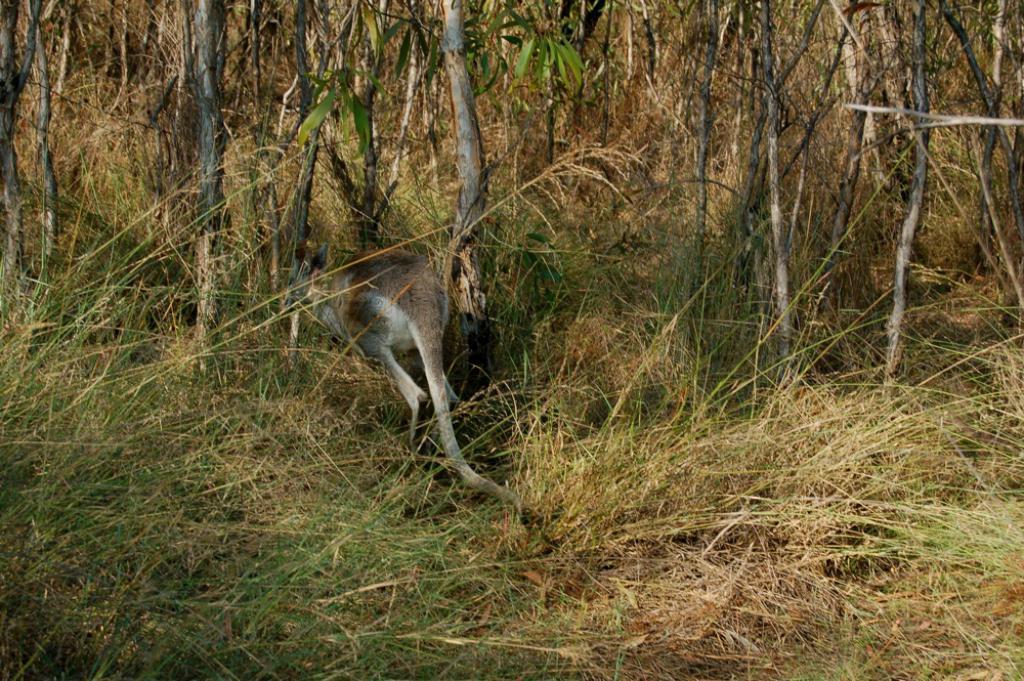Please provide a concise description of this image. We can see an animal on the grass and we can see trees. 